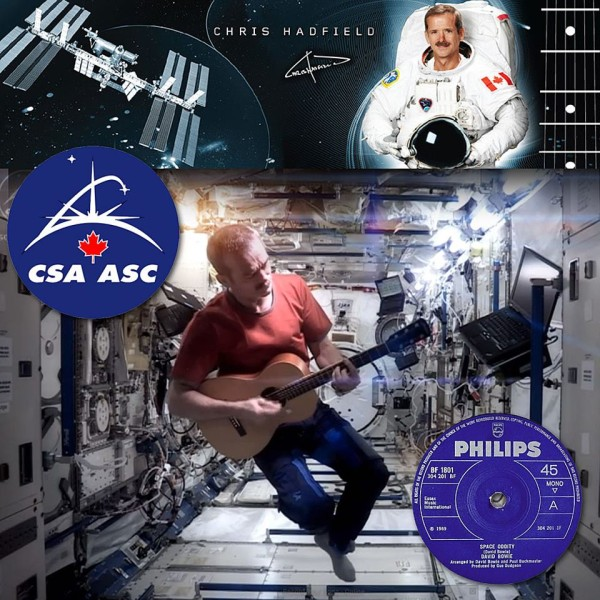Considering the elements surrounding the central image, what might be the significance of the song 'Space Oddity' in the context of this collage, and how does it relate to the person depicted? The choice of 'Space Oddity' in this collage goes beyond a mere musical selection; it deeply connects with Chris Hadfield's unique contribution to space culture. By performing 'Space Oddity' aboard the International Space Station, Hadfield not only showcased his musical talent but also highlighted themes of isolation and contemplation that astronauts commonly experience, as reflected in Bowie's lyrics. This song thus serves as a bridge between terrestrial life and the ethereal solitude of space, marking a memorable moment in space exploration. The collage celebrates this iconic performance, intertwining it with Hadfield’s identity as both an astronaut and a musician, thereby enriching our perception of space exploration through a cultural lens. 